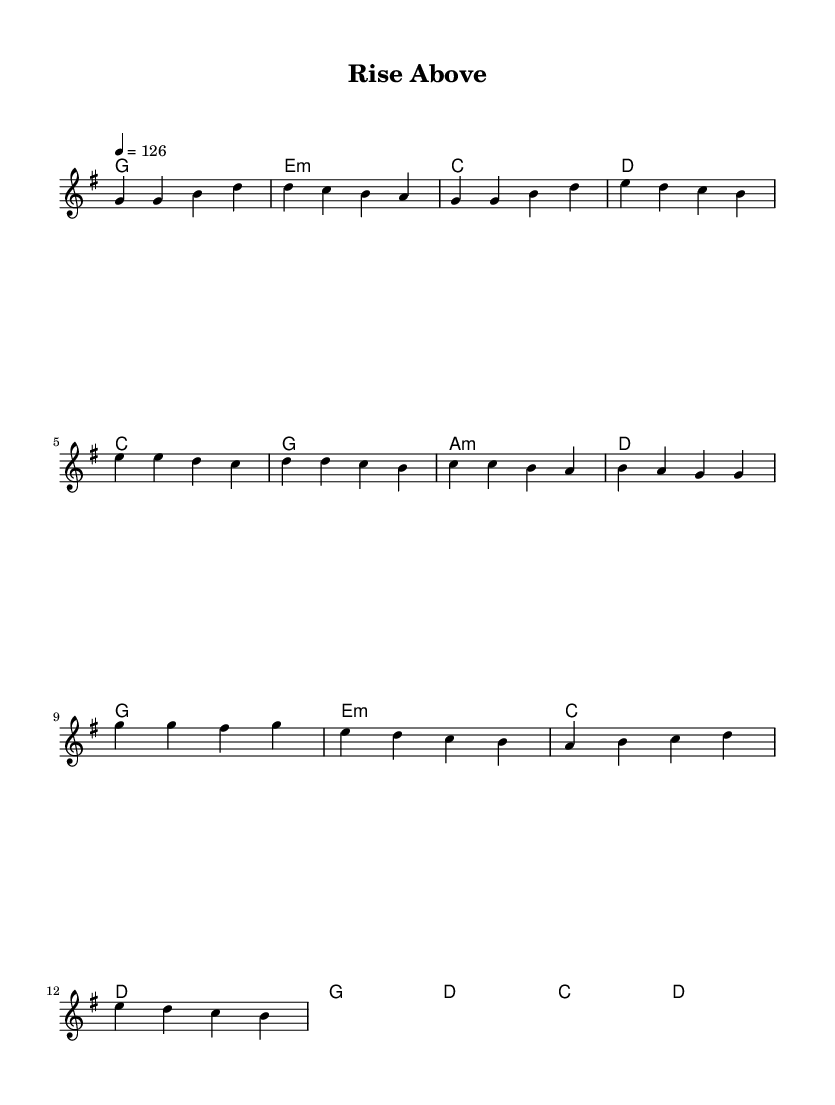What is the key signature of this music? The key signature is indicated by the appearance of the notes and the lack of sharps or flats, which corresponds to G major.
Answer: G major What is the time signature of this music? The time signature is located at the beginning of the staff, where it displays "4/4," indicating four beats per measure with a quarter note receiving one beat.
Answer: 4/4 What is the tempo marking of this music? The tempo is specified by the number that follows "tempo," which is 126 beats per minute, indicating the pace of the piece.
Answer: 126 How many measures are in the verse section? Counting the measures in the verse section, there are a total of four distinct measures that group together the musical ideas.
Answer: 4 What type of chord is the second chord in the chorus? The second chord in the chorus is identified as e minor, as indicated by the notation used in the chord line.
Answer: e minor Do any sections repeat in this music? The repeated sections can be determined by looking for identical melodic phrases, which exist in both the verse and chorus, indicating they share musical material.
Answer: Yes What is the overall theme of the lyrics suggested by the title? The title "Rise Above" implies a theme of overcoming challenges and achieving personal growth, which resonates with the uplifting nature of the song.
Answer: Overcoming challenges 